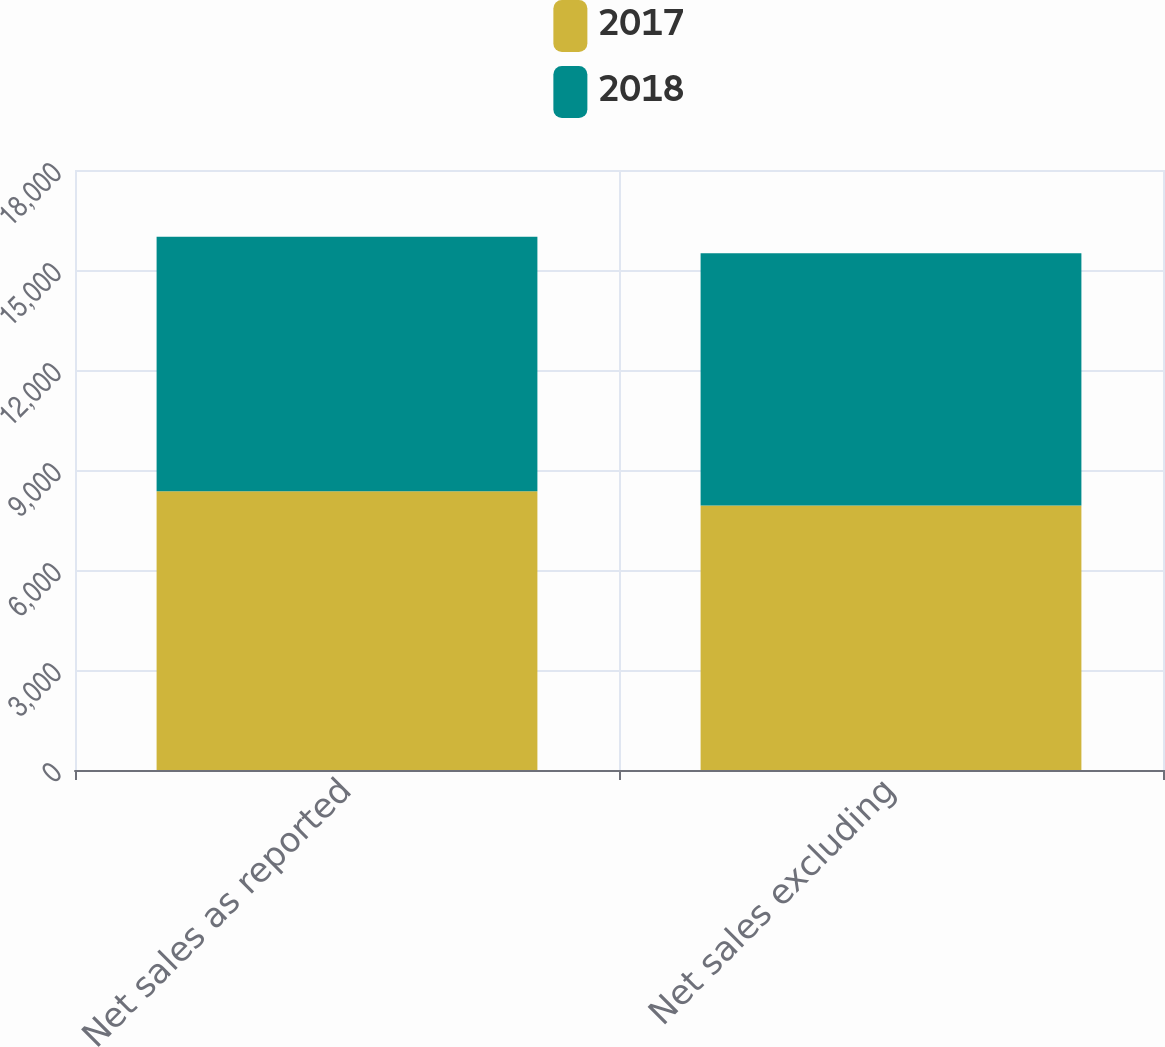Convert chart to OTSL. <chart><loc_0><loc_0><loc_500><loc_500><stacked_bar_chart><ecel><fcel>Net sales as reported<fcel>Net sales excluding<nl><fcel>2017<fcel>8359<fcel>7935<nl><fcel>2018<fcel>7642<fcel>7570<nl></chart> 